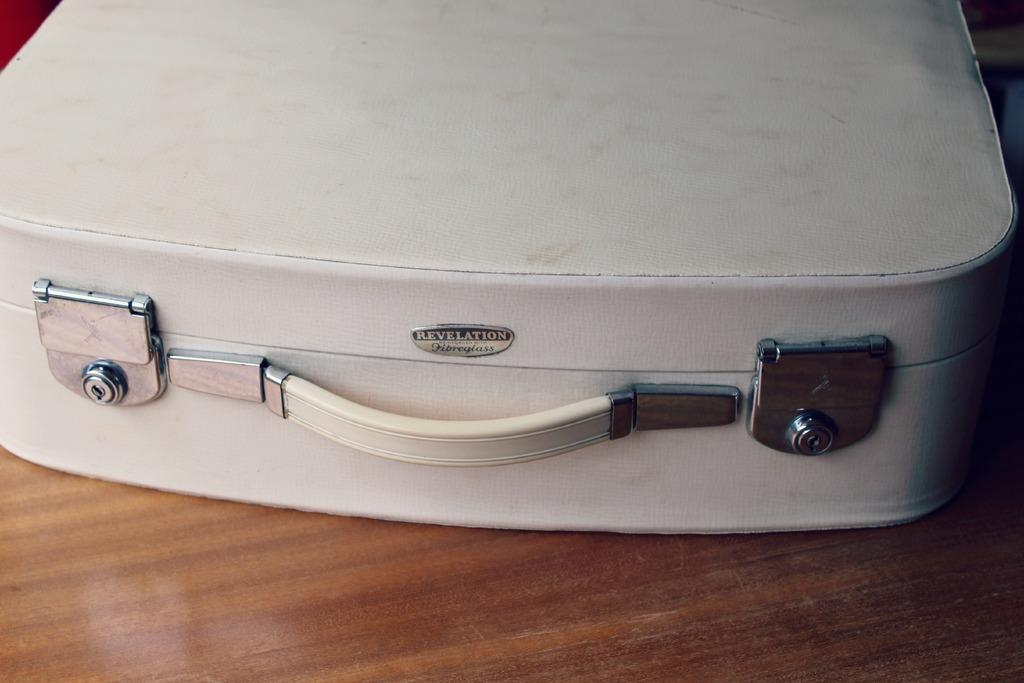What color is the suitcase that is visible in the image? The suitcase is white-colored in the image. Where is the suitcase located in the image? The suitcase is kept on a wooden table in the image. What type of ray can be seen swimming in the image? There is no ray present in the image; it features a white-colored suitcase on a wooden table. What type of school is depicted in the image? There is no school depicted in the image; it features a white-colored suitcase on a wooden table. 